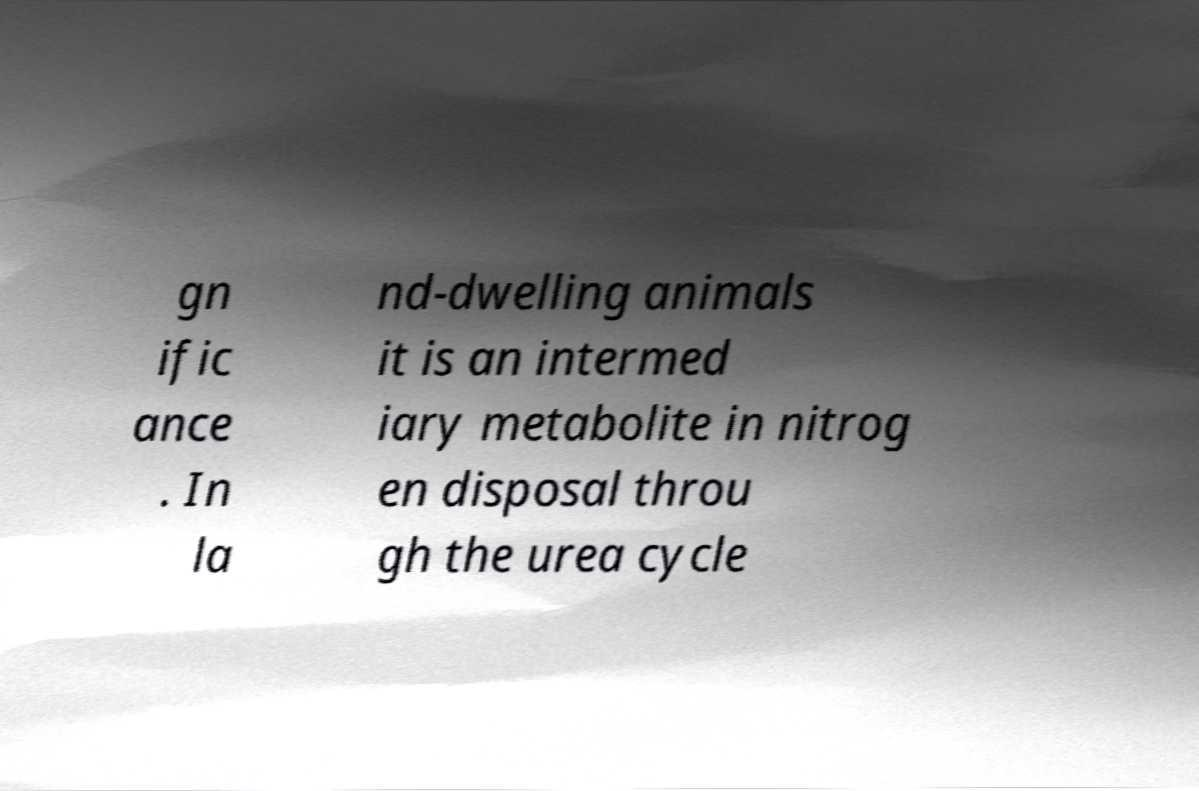Please identify and transcribe the text found in this image. gn ific ance . In la nd-dwelling animals it is an intermed iary metabolite in nitrog en disposal throu gh the urea cycle 